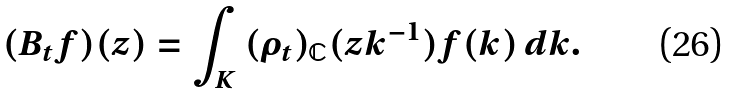Convert formula to latex. <formula><loc_0><loc_0><loc_500><loc_500>( B _ { t } f ) ( z ) = \int _ { K } \, ( \rho _ { t } ) _ { \mathbb { C } } ( z k ^ { - 1 } ) f ( k ) \, d k .</formula> 